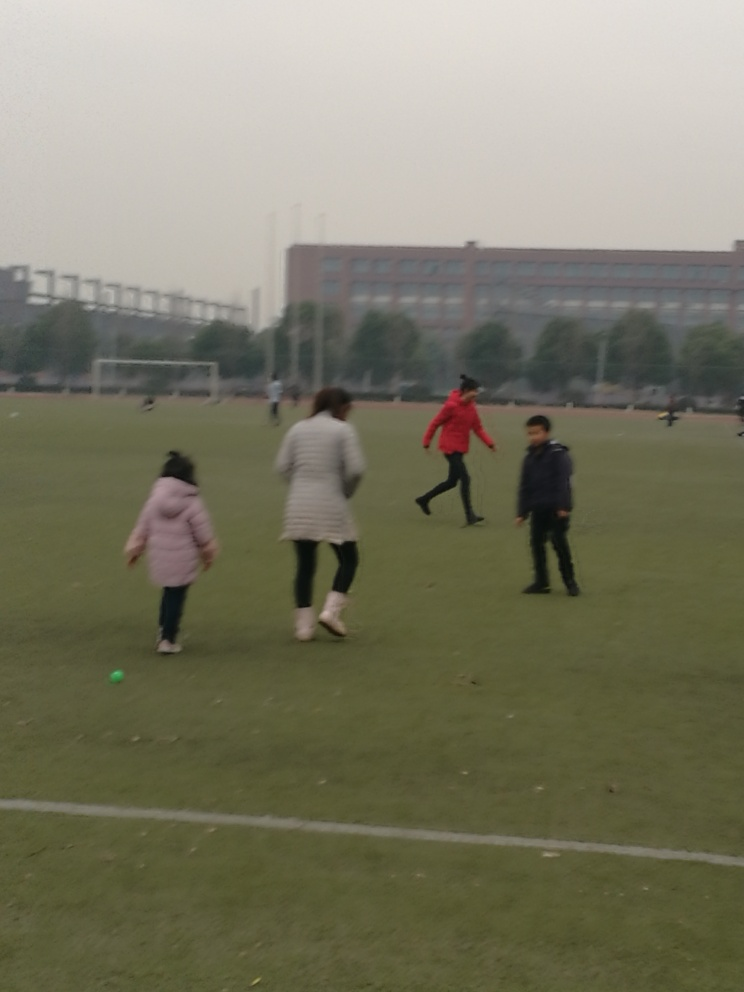Can you tell me about the weather or time of day in the image? The lighting in the image is quite diffuse, lacking strong shadows or brightness, which may indicate an overcast sky. Such conditions often occur during the cooler hours of the day, suggesting it might be either early morning or late afternoon. 